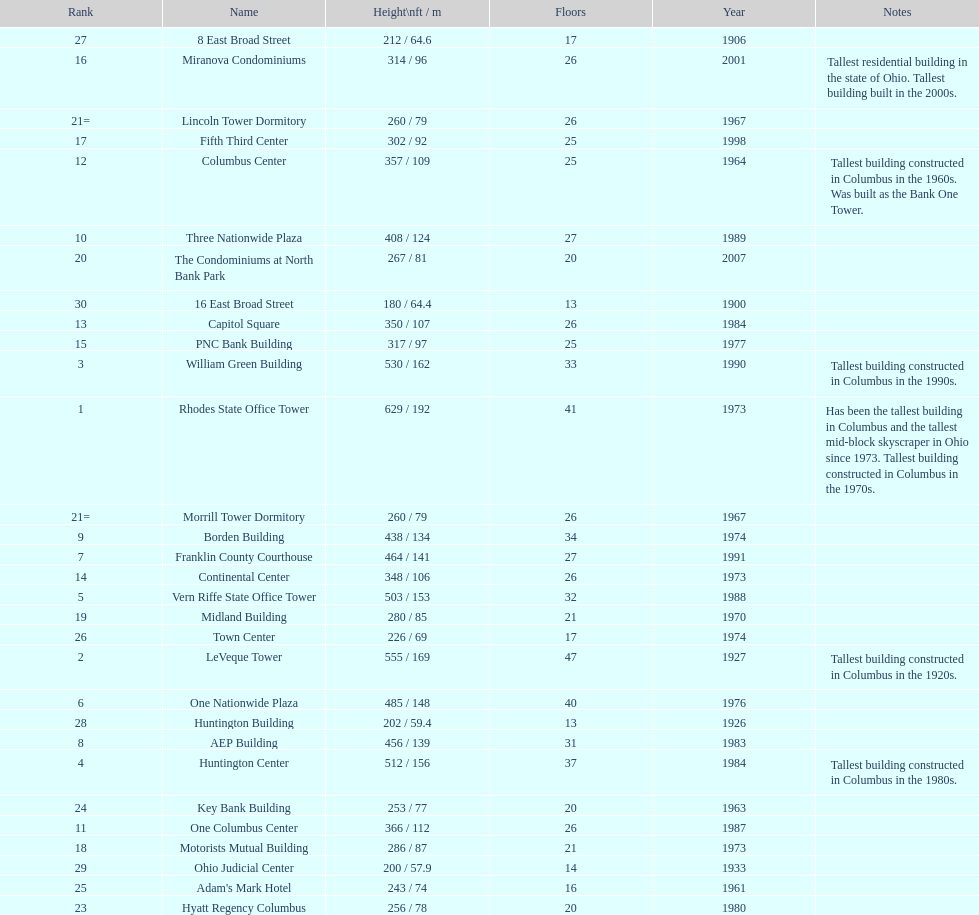What number of floors does the leveque tower have? 47. 